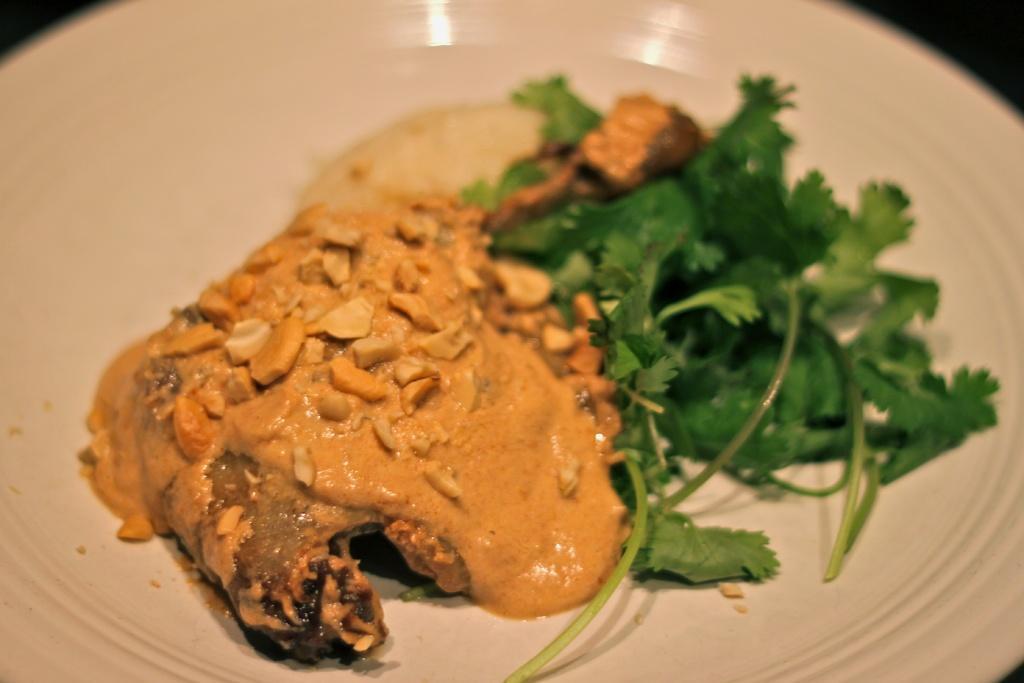Could you give a brief overview of what you see in this image? In this image I can see the plate with food. The plate is in white color and the food is in yellow, green and cream color. And there is a black background. 